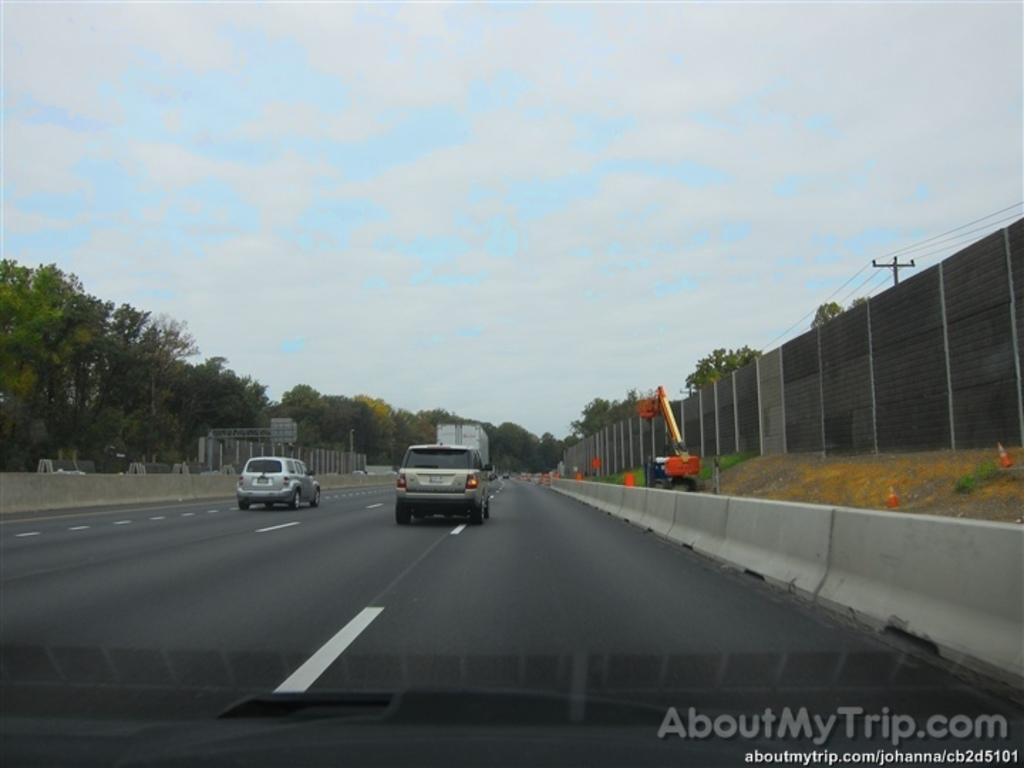Please provide a concise description of this image. This image is clicked outside. There are trees in the middle. There are vehicles in the middle. There is sky at the top. 